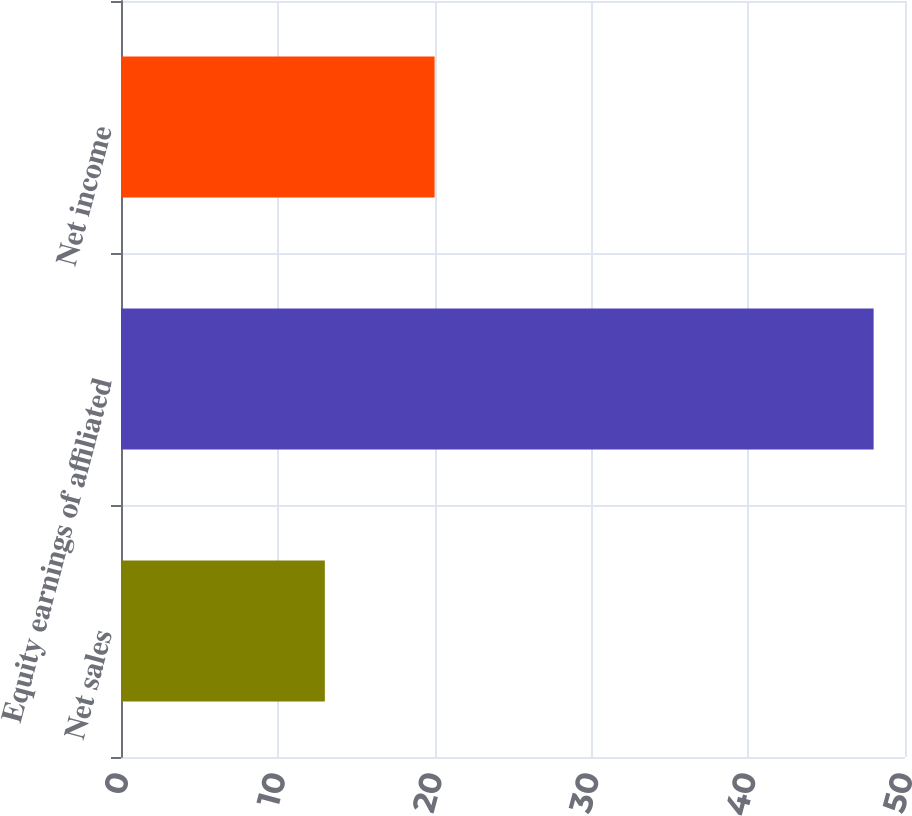Convert chart to OTSL. <chart><loc_0><loc_0><loc_500><loc_500><bar_chart><fcel>Net sales<fcel>Equity earnings of affiliated<fcel>Net income<nl><fcel>13<fcel>48<fcel>20<nl></chart> 